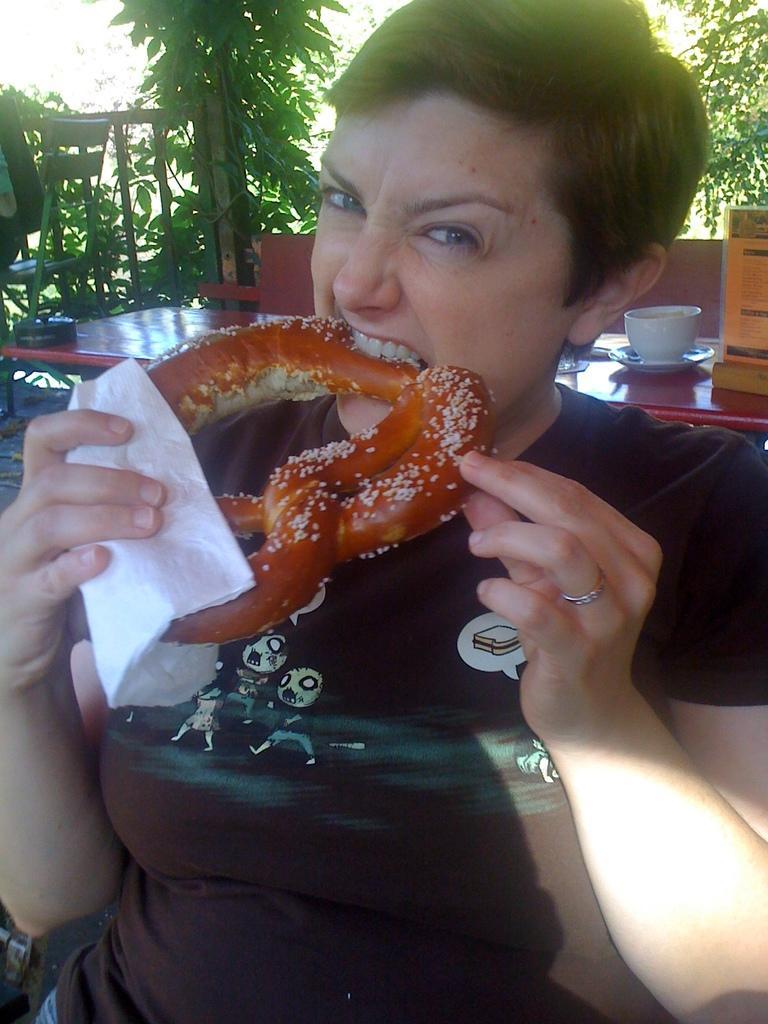Describe this image in one or two sentences. In the given image we can see a women, she is having a food item in her hand. Back of her there is a table on the table we can see a teacup. There is a chair and a plant. 